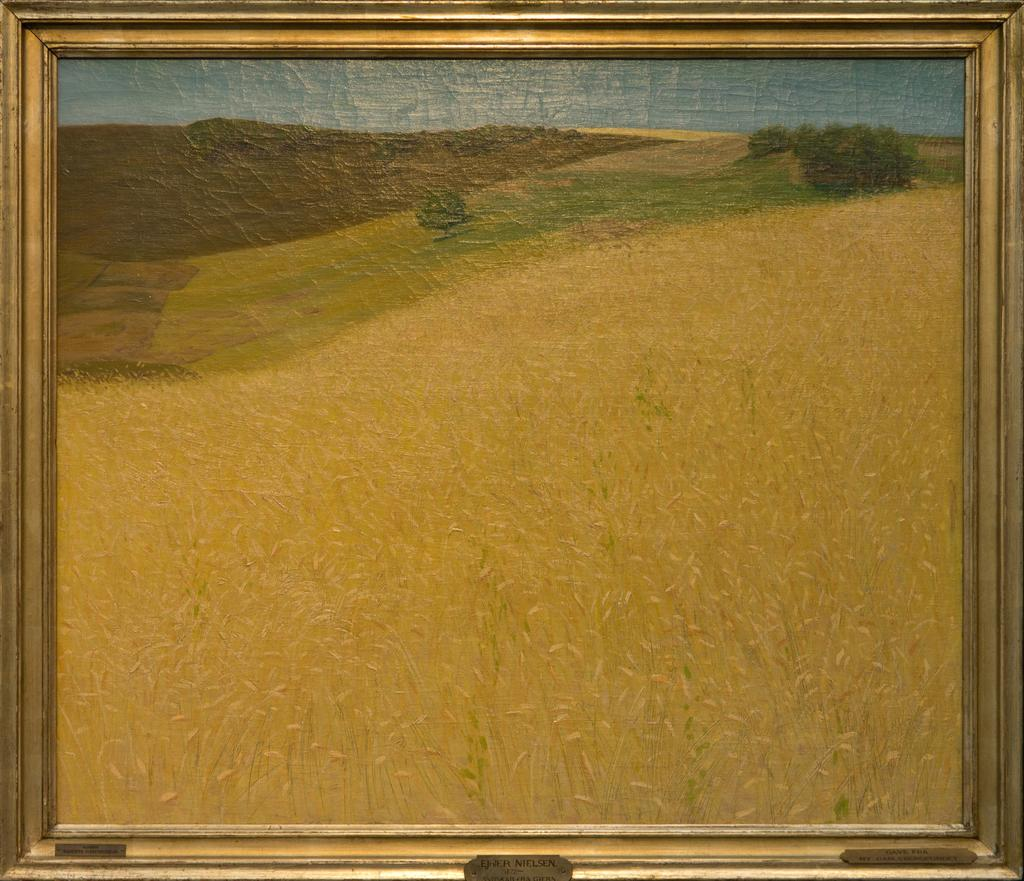What object is present in the image that holds a photo? There is a photo frame in the image. What is depicted in the photo inside the frame? The photo contains grass, trees, a hill, and sky. Can you describe the landscape shown in the photo? The photo depicts a landscape with grass, trees, a hill, and sky. What letter can be seen carved into the hill in the photo? There is no letter visible in the photo; it only shows a landscape with grass, trees, a hill, and sky. 